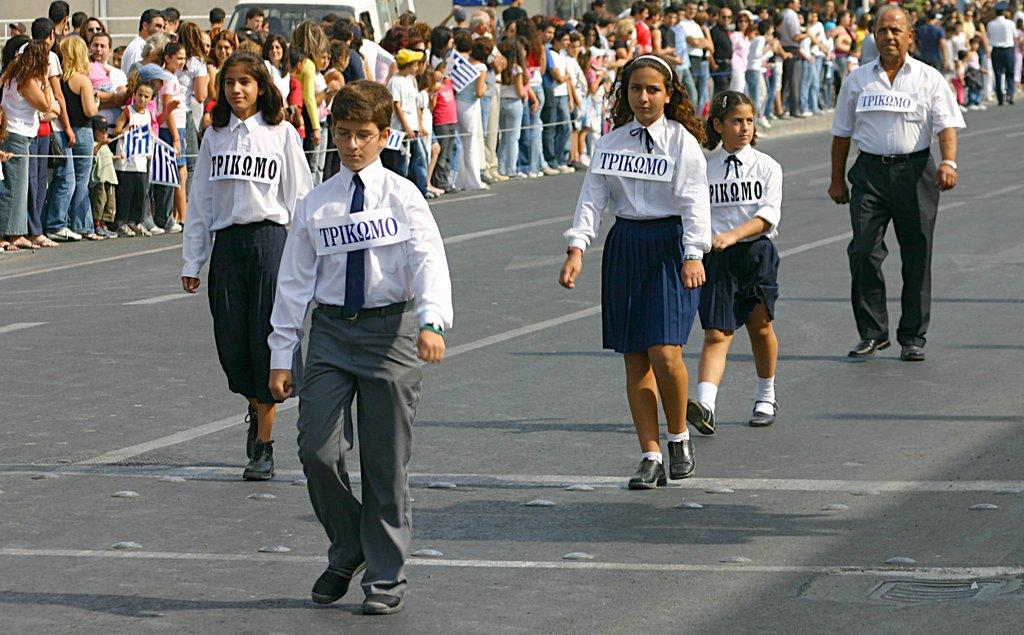What is happening in the image? The image appears to depict an event. Can you describe the people in the image? There are people walking on the road, and they are wearing badges on their shirts. What is the general atmosphere in the image? There is a large crowd around the road, suggesting a busy or lively event. What time of day is it in the image, and what does your uncle think about it? The time of day cannot be determined from the image, and there is no mention of an uncle in the provided facts. 